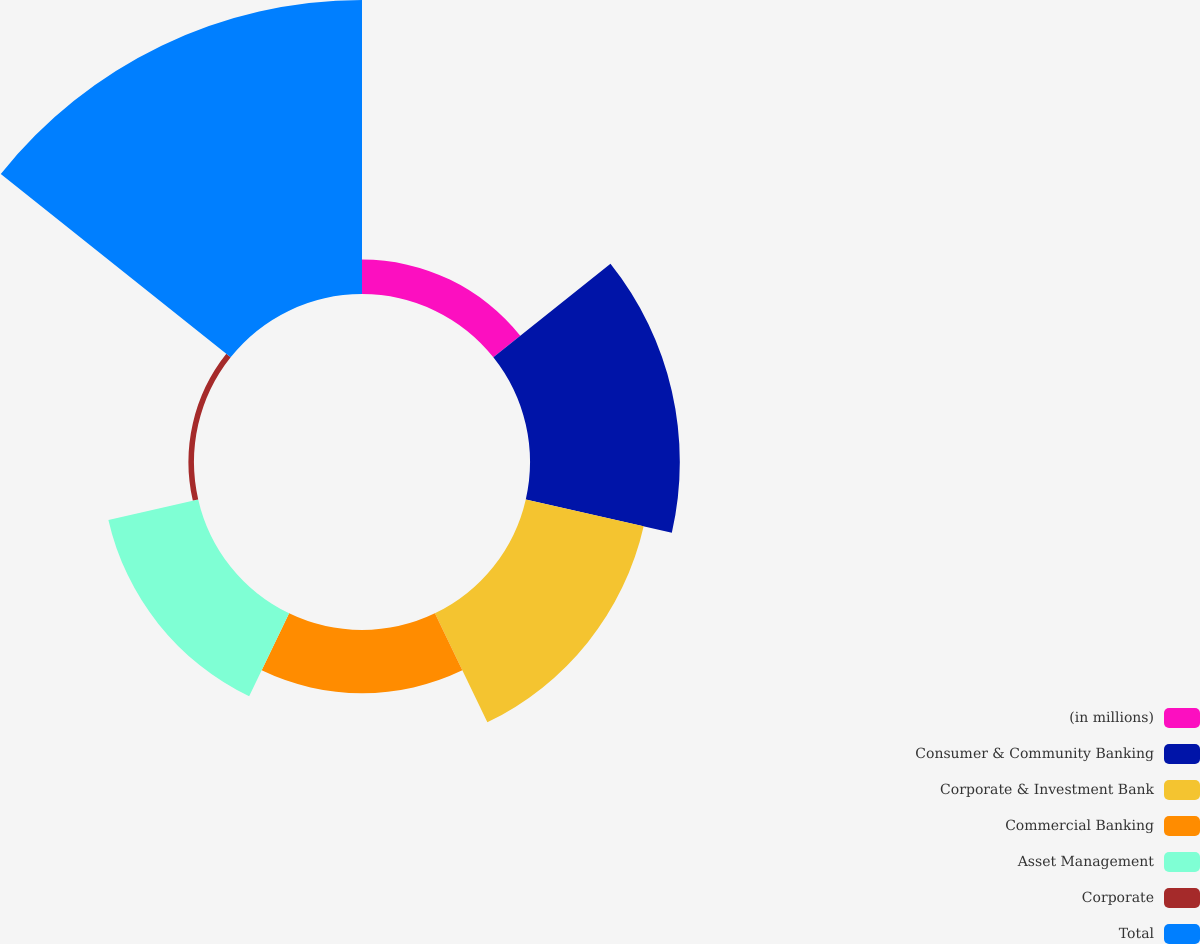Convert chart to OTSL. <chart><loc_0><loc_0><loc_500><loc_500><pie_chart><fcel>(in millions)<fcel>Consumer & Community Banking<fcel>Corporate & Investment Bank<fcel>Commercial Banking<fcel>Asset Management<fcel>Corporate<fcel>Total<nl><fcel>4.53%<fcel>19.71%<fcel>15.91%<fcel>8.32%<fcel>12.12%<fcel>0.73%<fcel>38.68%<nl></chart> 